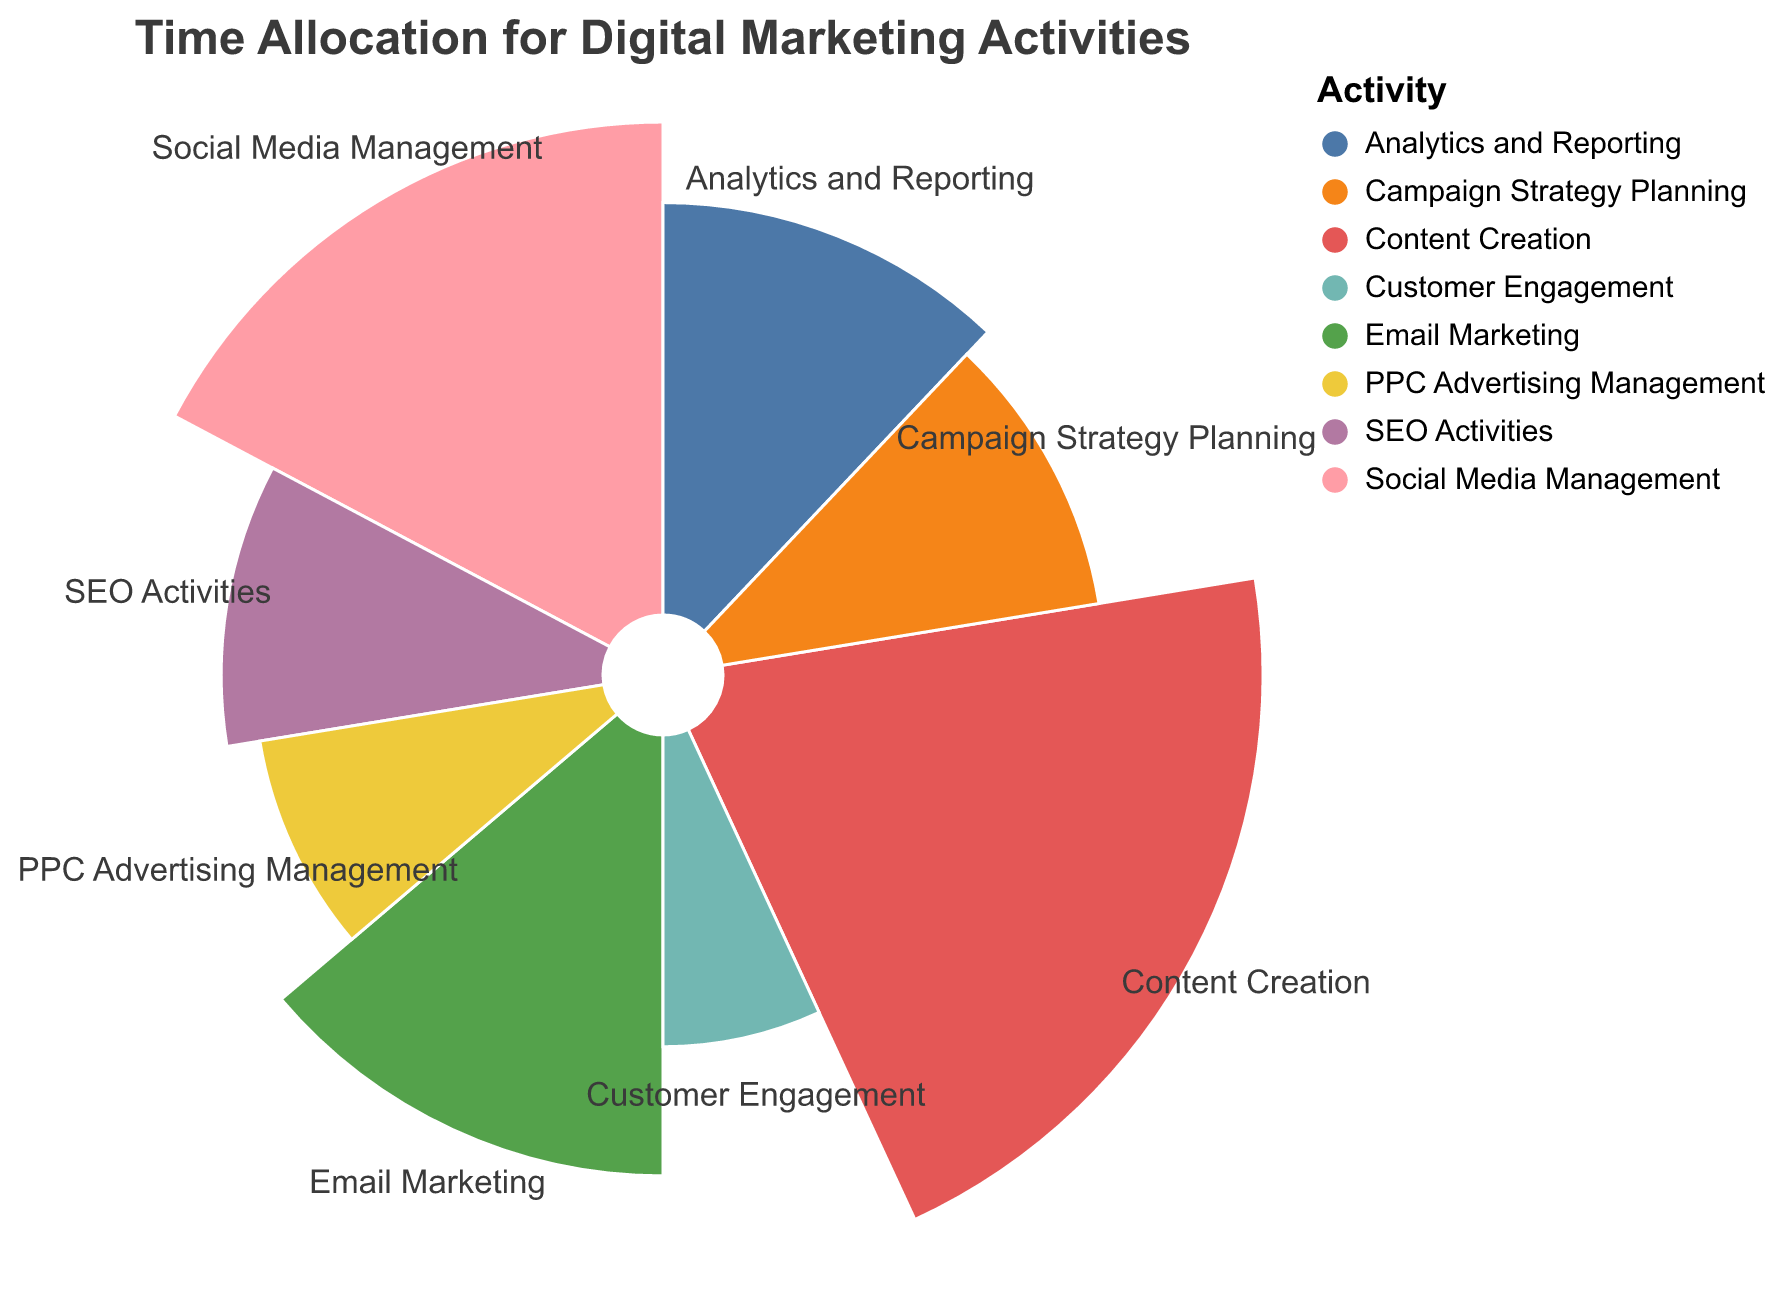What is the title of the figure? The title of the figure is usually displayed prominently at the top.
Answer: Time Allocation for Digital Marketing Activities Which activity has the highest average hours per week? Identify the largest segment in the Polar Chart. This segment corresponds to the activity with the highest hours.
Answer: Content Creation What is the average number of hours spent on Email Marketing each week? Look for the segment labeled "Email Marketing" and note the corresponding average hours.
Answer: 8 How many average hours per week are allocated to PPC Advertising Management? Locate the segment labeled "PPC Advertising Management" and refer to its average hours.
Answer: 5 Which two activities combined account for 12 hours on average each week? Check which segments add up to 12 hours.
Answer: SEO Activities and Campaign Strategy Planning How much more time is spent on Social Media Management compared to Customer Engagement? Subtract the average hours for Customer Engagement from the average hours for Social Media Management (10 - 4).
Answer: 6 hours What is the total average number of hours spent on Analytics and Reporting and PPC Advertising Management combined? Sum the average hours for Analytics and Reporting and PPC Advertising Management (7 + 5).
Answer: 12 Which activity has fewer average hours per week: SEO Activities or Campaign Strategy Planning? Compare the average hours for both activities.
Answer: They have the same, 6 hours each How does the average time spent on Content Creation compare to Email Marketing? Subtract the average hours for Email Marketing from Content Creation (12 - 8).
Answer: 4 more hours Determine the total average hours per week spent on all activities. Sum up the hours of all the activities (10 + 12 + 8 + 6 + 5 + 7 + 4 + 6).
Answer: 58 hours 